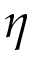Convert formula to latex. <formula><loc_0><loc_0><loc_500><loc_500>\eta</formula> 